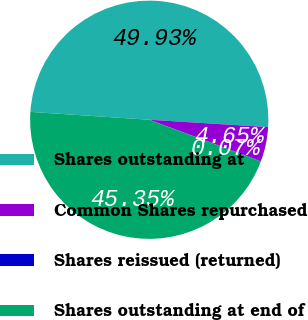<chart> <loc_0><loc_0><loc_500><loc_500><pie_chart><fcel>Shares outstanding at<fcel>Common Shares repurchased<fcel>Shares reissued (returned)<fcel>Shares outstanding at end of<nl><fcel>49.93%<fcel>4.65%<fcel>0.07%<fcel>45.35%<nl></chart> 